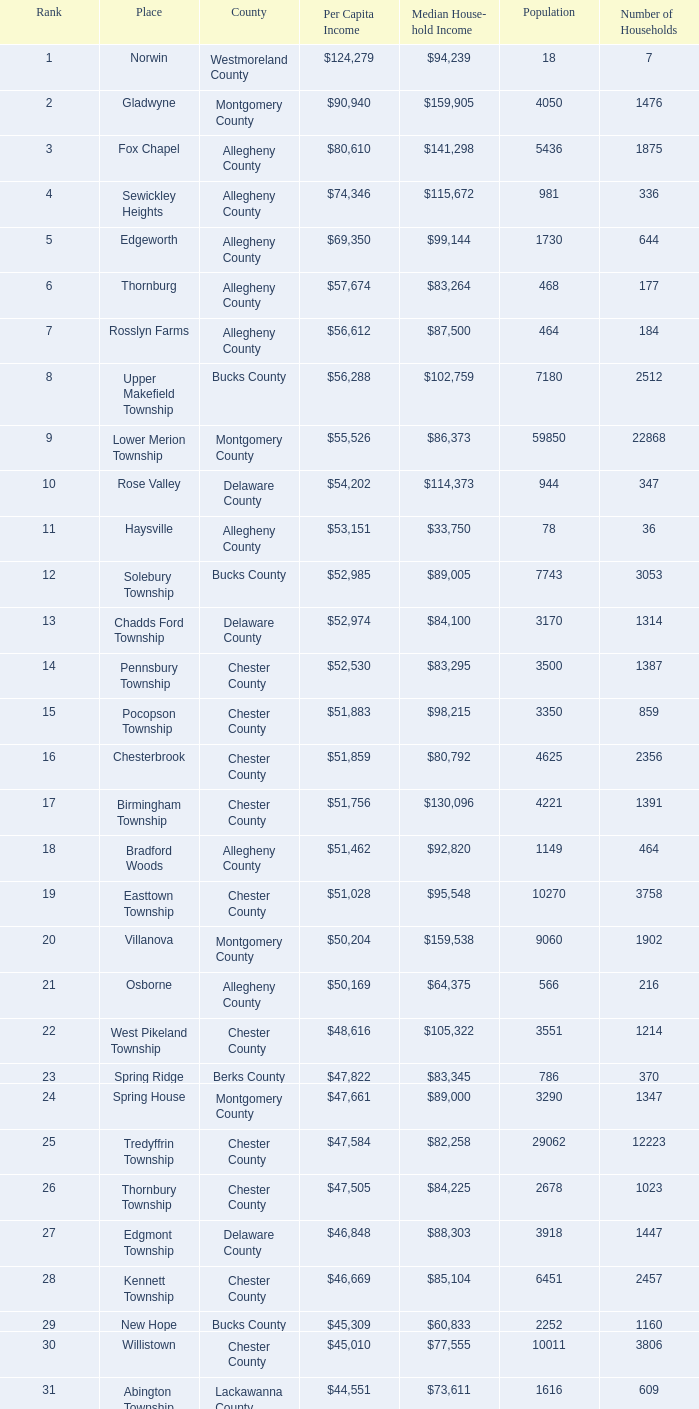Can you provide the median income of households in woodside? $121,151. 